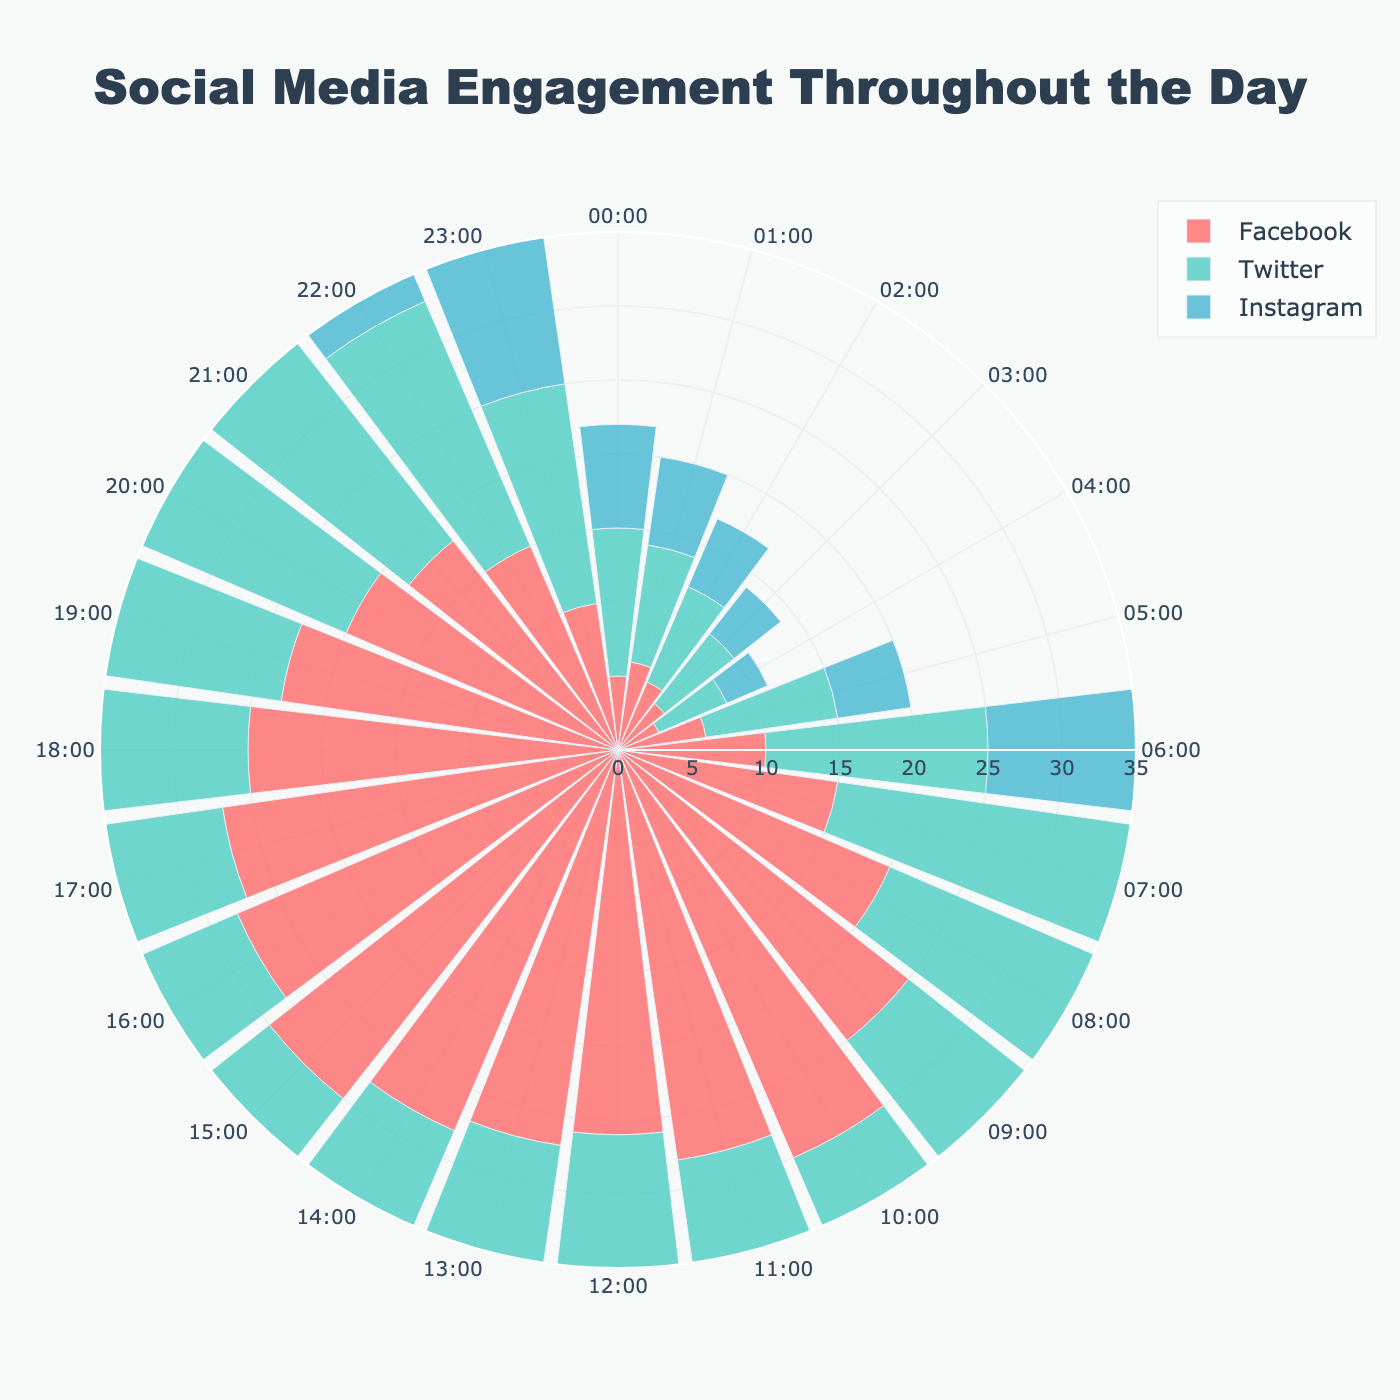What is the title of the figure? The title is usually located at the top of the chart. It provides a succinct description of what the chart represents. Here, it reads "Social Media Engagement Throughout the Day."
Answer: Social Media Engagement Throughout the Day Which social media platform has the highest engagement at 10:00? Look at the figure's data points for 10:00 and identify the platform with the largest radius (distance from the center). For 10:00, the highest engagement is observed in the Twitter group.
Answer: Twitter How does Facebook engagement at 09:00 compare to Twitter engagement at the same time? At 09:00, measure the radial length for both Facebook and Twitter on the polar plot. Facebook has an engagement of 25, while Twitter has 30. Hence, Twitter engagement is higher.
Answer: Twitter engagement is higher What time of day does Instagram see its peak engagement? Examine the radial length of the Instagram plot over the entire day. Peak engagement occurs where the radius is the longest. The longest radius for Instagram appears at 10:00.
Answer: 10:00 If combined, what is the total social media engagement (Facebook, Twitter, Instagram) at 17:00? Add the radial lengths for Facebook, Twitter, and Instagram at 17:00. The values are 27 (Facebook), 30 (Twitter), and 24 (Instagram). Summing these values: 27 + 30 + 24 = 81.
Answer: 81 Which platform has a more stable (less variable) engagement throughout the day? Compare the ranges and fluctuations of the radial lengths for Facebook, Twitter, and Instagram. Instagram seems to have fewer drastic changes in its radial length throughout the day compared to Facebook and Twitter.
Answer: Instagram At what time is the engagement on LinkedIn at its lowest? Identify the smallest radial length for LinkedIn. According to the data, the minimum engagement is at 03:00 and 04:00 with a value of 1 each.
Answer: 03:00 and 04:00 During which hour does Twitter engagement drop below 20 for the first time in the evening? Move from the end of the day (22:00) backward, and the first instance where Twitter engagement drops below 20 is 21:00.
Answer: 21:00 What is the average Facebook engagement from 00:00 to 05:00? Calculate the mean Facebook engagement for the first six hours: (5 + 6 + 5 + 4 + 3 + 6) / 6 = 29 / 6 ≈ 4.83.
Answer: 4.83 